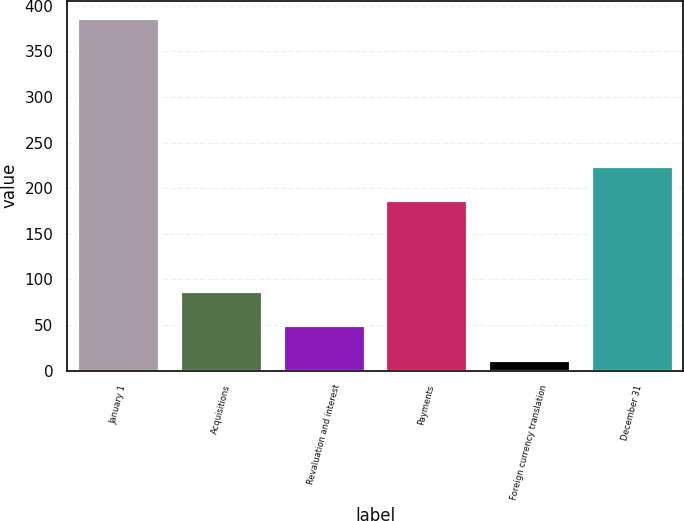Convert chart to OTSL. <chart><loc_0><loc_0><loc_500><loc_500><bar_chart><fcel>January 1<fcel>Acquisitions<fcel>Revaluation and interest<fcel>Payments<fcel>Foreign currency translation<fcel>December 31<nl><fcel>386.1<fcel>86.82<fcel>49.41<fcel>187<fcel>12<fcel>224.41<nl></chart> 